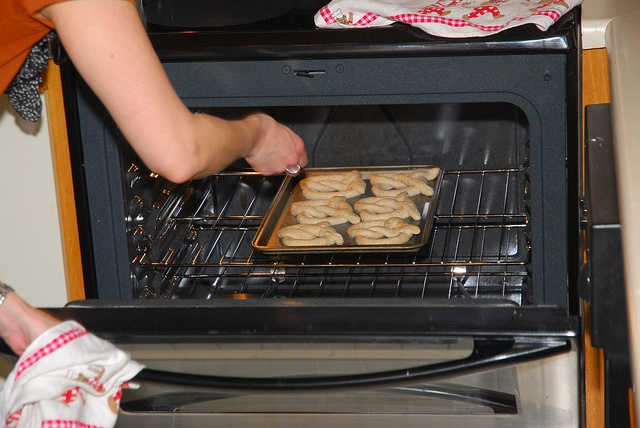Describe the objects in this image and their specific colors. I can see oven in black, brown, gray, and tan tones and people in brown, tan, and salmon tones in this image. 